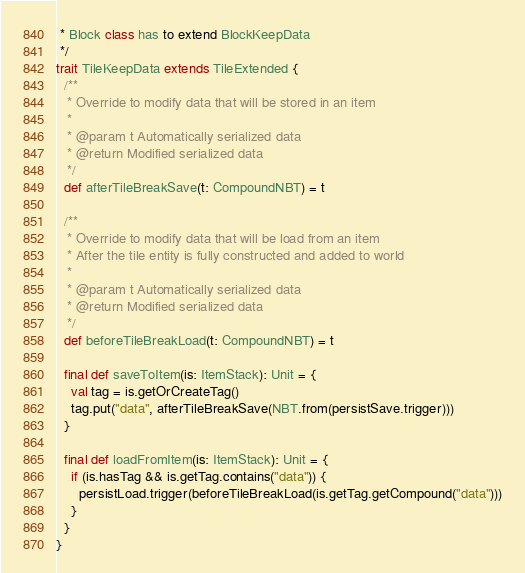<code> <loc_0><loc_0><loc_500><loc_500><_Scala_> * Block class has to extend BlockKeepData
 */
trait TileKeepData extends TileExtended {
  /**
   * Override to modify data that will be stored in an item
   *
   * @param t Automatically serialized data
   * @return Modified serialized data
   */
  def afterTileBreakSave(t: CompoundNBT) = t

  /**
   * Override to modify data that will be load from an item
   * After the tile entity is fully constructed and added to world
   *
   * @param t Automatically serialized data
   * @return Modified serialized data
   */
  def beforeTileBreakLoad(t: CompoundNBT) = t

  final def saveToItem(is: ItemStack): Unit = {
    val tag = is.getOrCreateTag()
    tag.put("data", afterTileBreakSave(NBT.from(persistSave.trigger)))
  }

  final def loadFromItem(is: ItemStack): Unit = {
    if (is.hasTag && is.getTag.contains("data")) {
      persistLoad.trigger(beforeTileBreakLoad(is.getTag.getCompound("data")))
    }
  }
}
</code> 